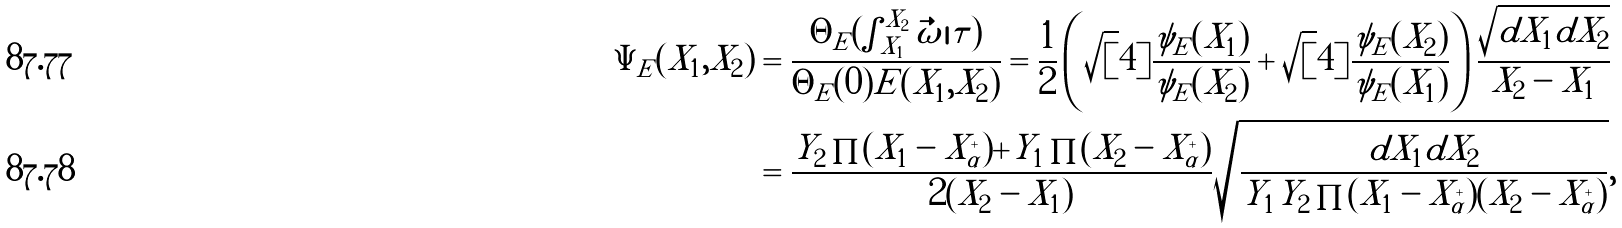Convert formula to latex. <formula><loc_0><loc_0><loc_500><loc_500>\Psi _ { E } ( X _ { 1 } , X _ { 2 } ) & = \frac { \Theta _ { E } ( \int ^ { X _ { 2 } } _ { X _ { 1 } } \vec { \omega } | \tau ) } { \Theta _ { E } ( 0 ) E ( X _ { 1 } , X _ { 2 } ) } = \frac { 1 } { 2 } \left ( \sqrt { [ } 4 ] { \frac { \psi _ { E } ( X _ { 1 } ) } { \psi _ { E } ( X _ { 2 } ) } } + \sqrt { [ } 4 ] { \frac { \psi _ { E } ( X _ { 2 } ) } { \psi _ { E } ( X _ { 1 } ) } } \right ) \frac { \sqrt { d X _ { 1 } d X _ { 2 } } } { X _ { 2 } - X _ { 1 } } \\ & = \frac { Y _ { 2 } \prod ( X _ { 1 } - X _ { \alpha } ^ { + } ) + Y _ { 1 } \prod ( X _ { 2 } - X _ { \alpha } ^ { + } ) } { 2 ( X _ { 2 } - X _ { 1 } ) } \sqrt { \frac { d X _ { 1 } d X _ { 2 } } { Y _ { 1 } Y _ { 2 } \prod ( X _ { 1 } - X _ { \alpha } ^ { + } ) ( X _ { 2 } - X _ { \alpha } ^ { + } ) } } ,</formula> 